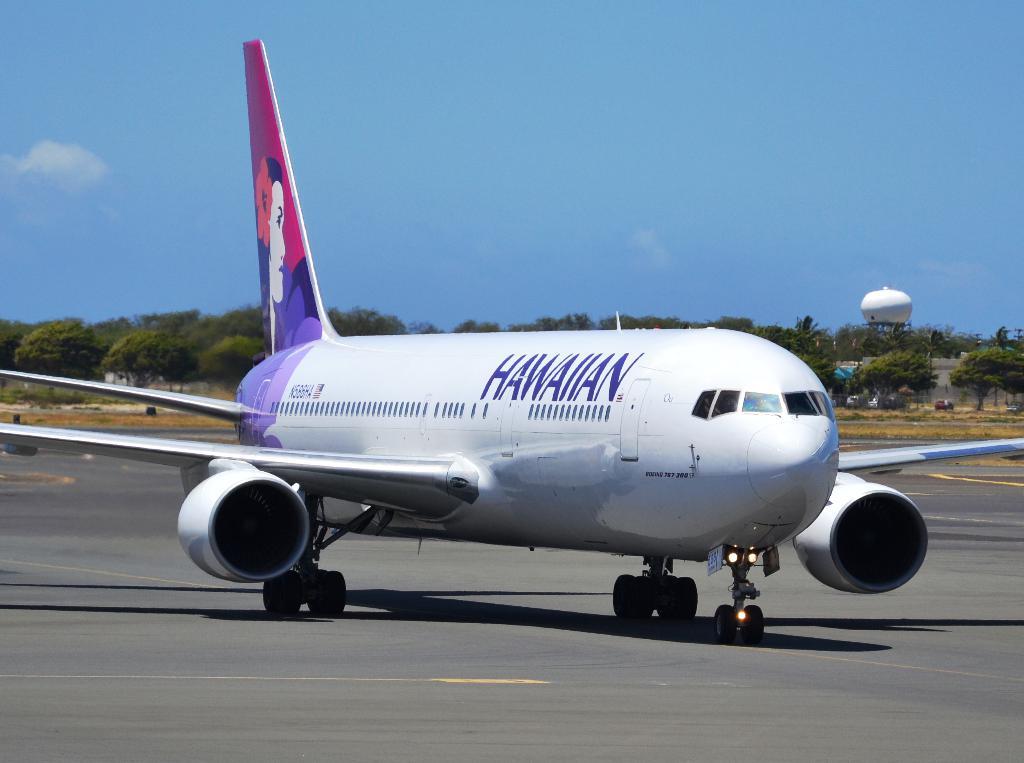What does it say on the side of the plane?
Offer a very short reply. Hawaiian. 